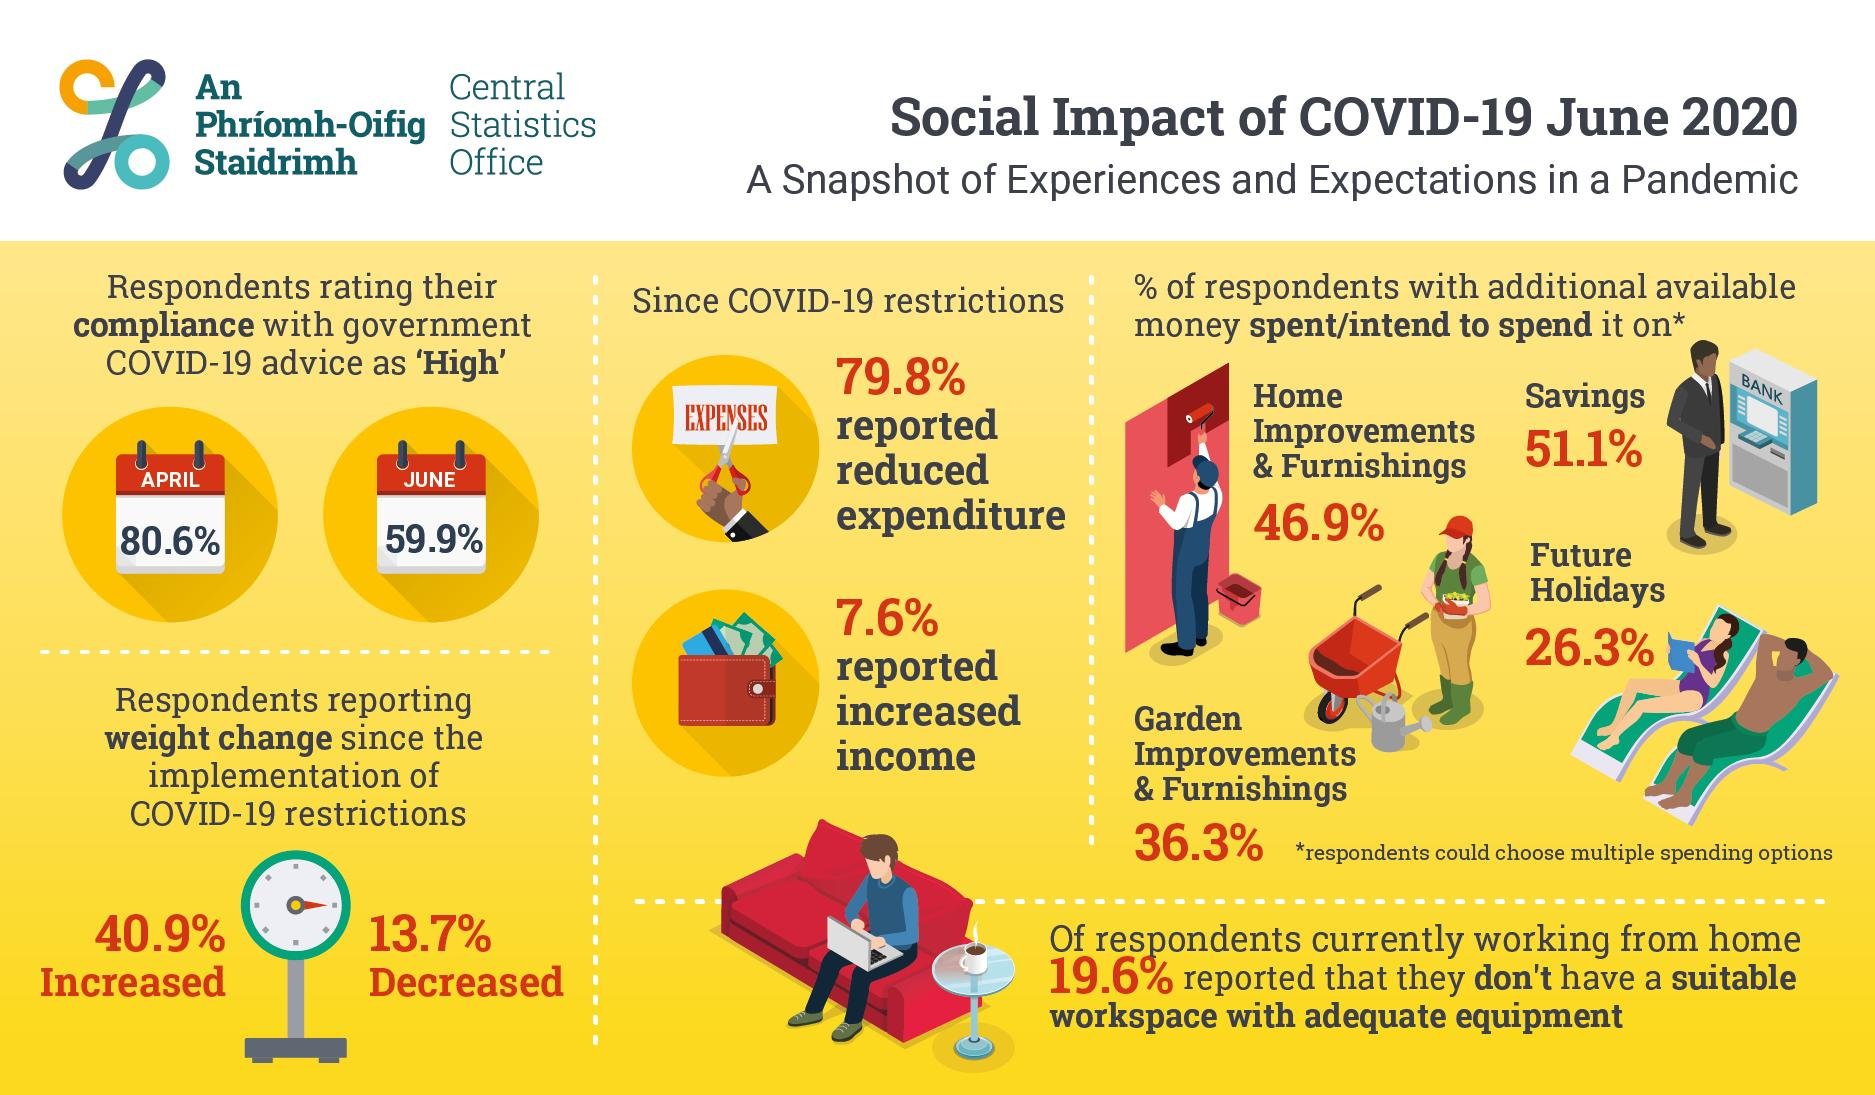Outline some significant characteristics in this image. During the lockdown, 40.9% of individuals gained additional body mass. According to the given statistic, a significant 26.3% of people are likely to save their money and put it towards vacations. During the lockdown, 13.7% of individuals experienced a loss of body mass. A recent study found that 59.9% of people complied with government restrictions in June. The number of people who comply with the government decreased by 20.7% from April to June. 